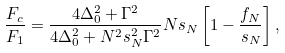<formula> <loc_0><loc_0><loc_500><loc_500>\frac { F _ { c } } { F _ { 1 } } = \frac { 4 \Delta _ { 0 } ^ { 2 } + \Gamma ^ { 2 } } { 4 \Delta _ { 0 } ^ { 2 } + N ^ { 2 } s _ { N } ^ { 2 } \Gamma ^ { 2 } } N s _ { N } \left [ 1 - \frac { f _ { N } } { s _ { N } } \right ] ,</formula> 